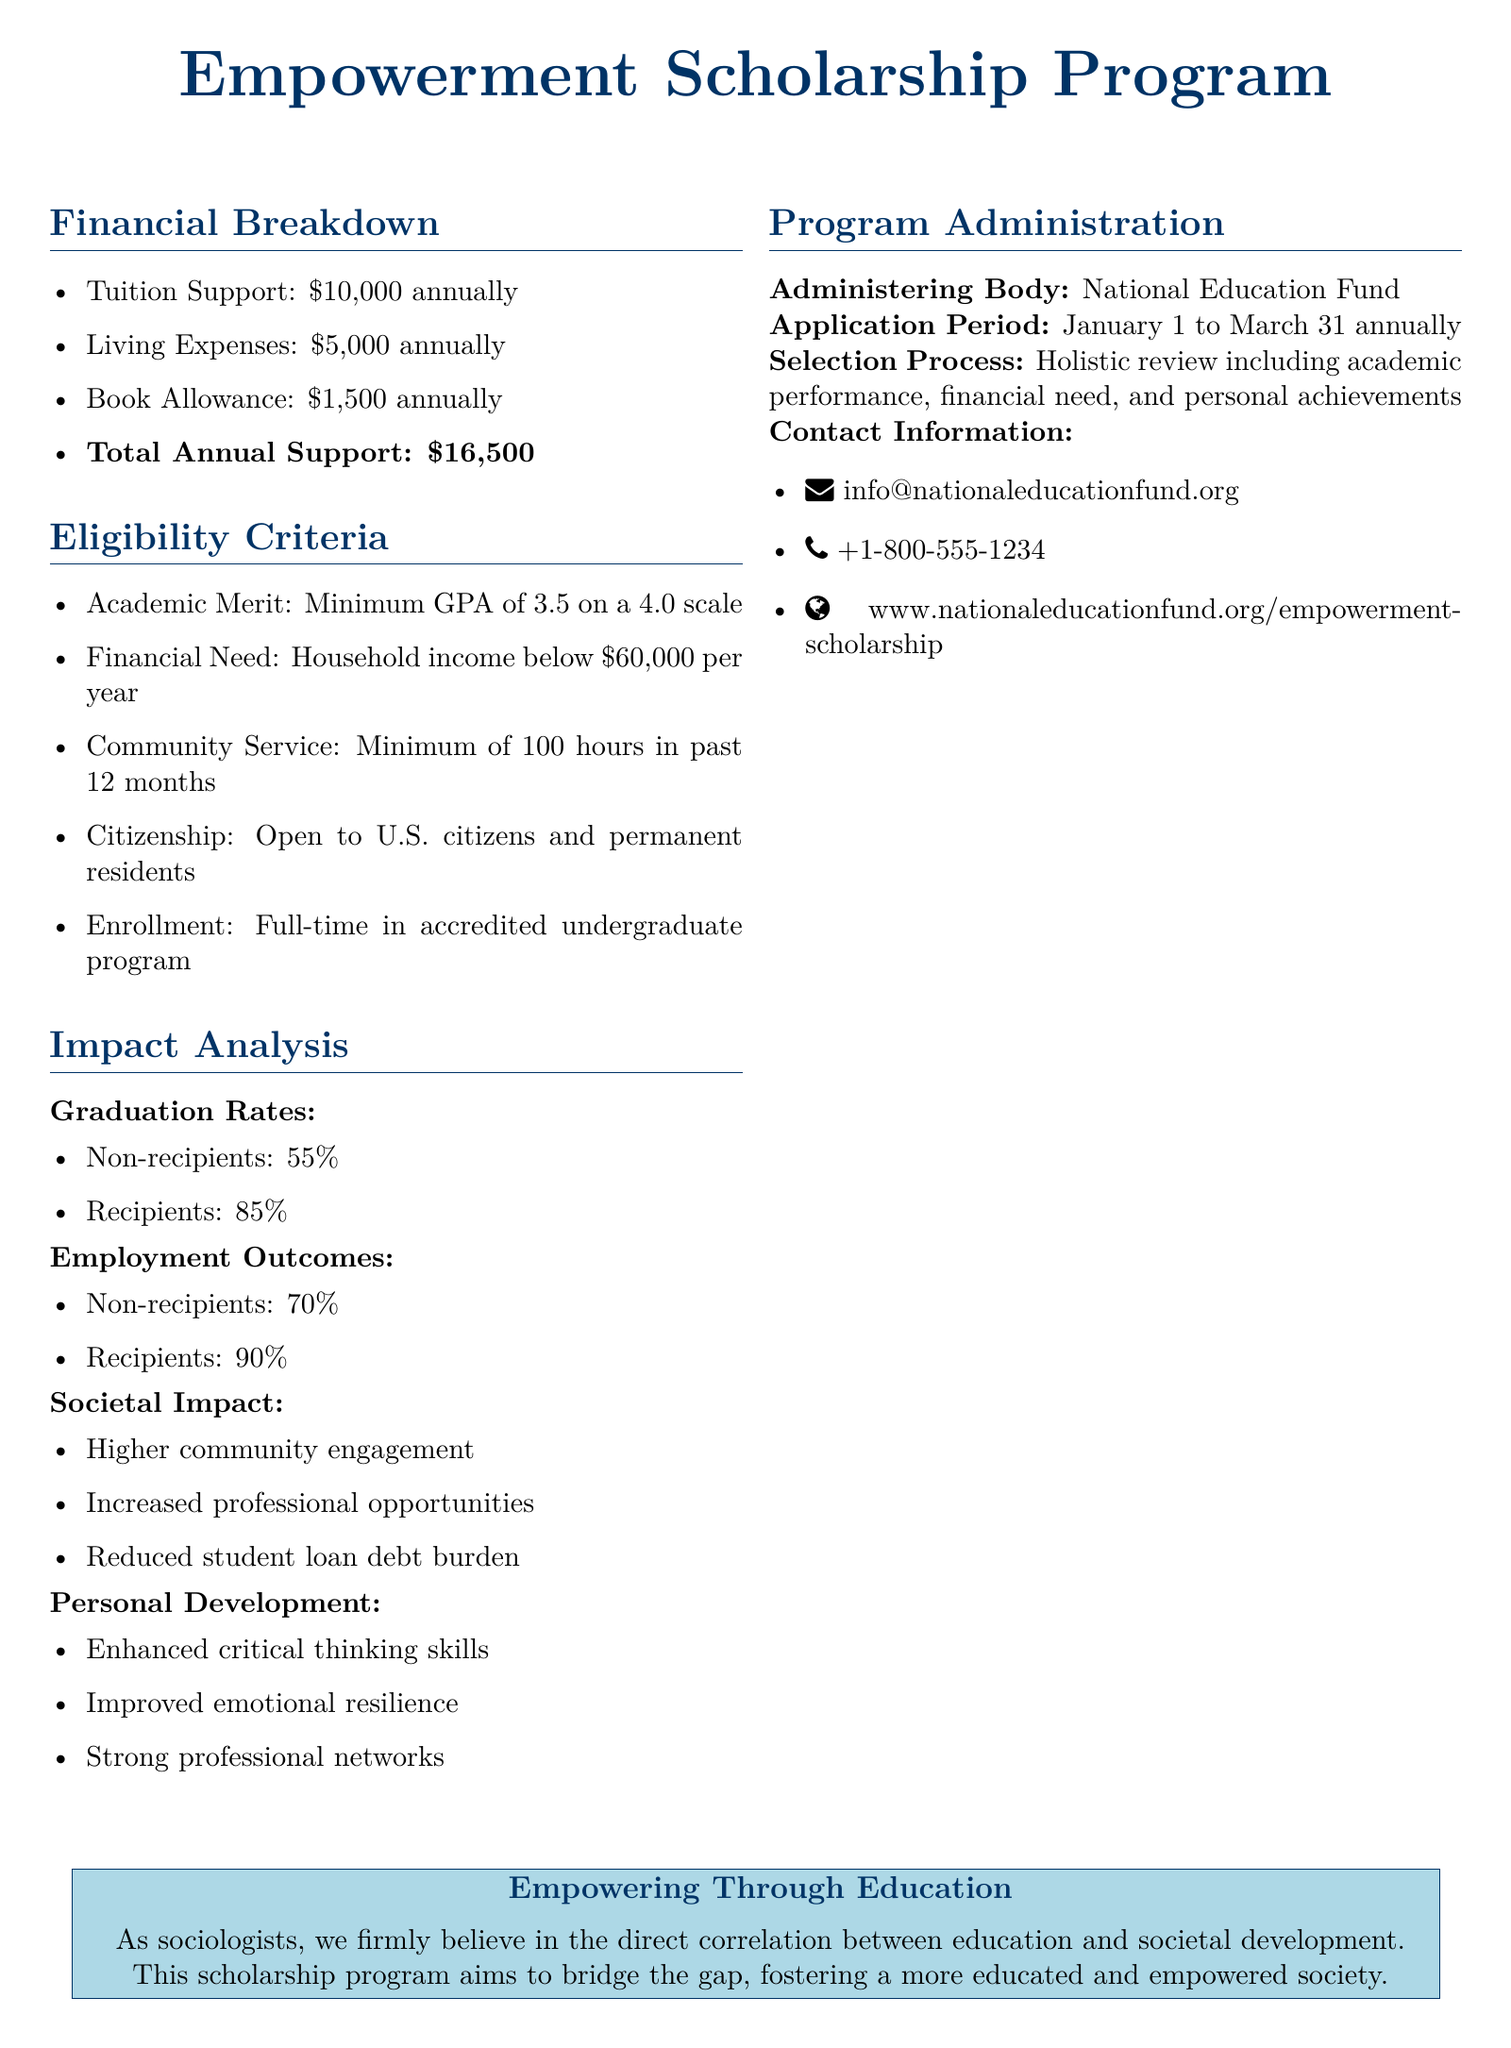What is the total annual support for the scholarship program? The total annual support is calculated from tuition support, living expenses, and book allowance, which sum up to $10,000 + $5,000 + $1,500.
Answer: $16,500 What is the minimum GPA required for eligibility? The eligibility criteria specify that applicants must have a minimum GPA of 3.5 on a 4.0 scale.
Answer: 3.5 What is the application period for the scholarship? The document states that the application period runs from January 1 to March 31 annually.
Answer: January 1 to March 31 What percentage of recipients graduate from the program? The impact analysis section indicates that 85% of recipients graduate.
Answer: 85% What is the financial need eligibility criterion based on household income? According to the eligibility criteria, the household income must be below $60,000 per year.
Answer: $60,000 What body administers the Empowerment Scholarship Program? The administering body for the scholarship program is identified as the National Education Fund.
Answer: National Education Fund How many community service hours are required for eligibility? The eligibility criteria mention a requirement of a minimum of 100 hours of community service in the past 12 months.
Answer: 100 hours What is the stated societal impact of the scholarship program? The impact analysis highlights several areas, one of which is higher community engagement.
Answer: Higher community engagement 